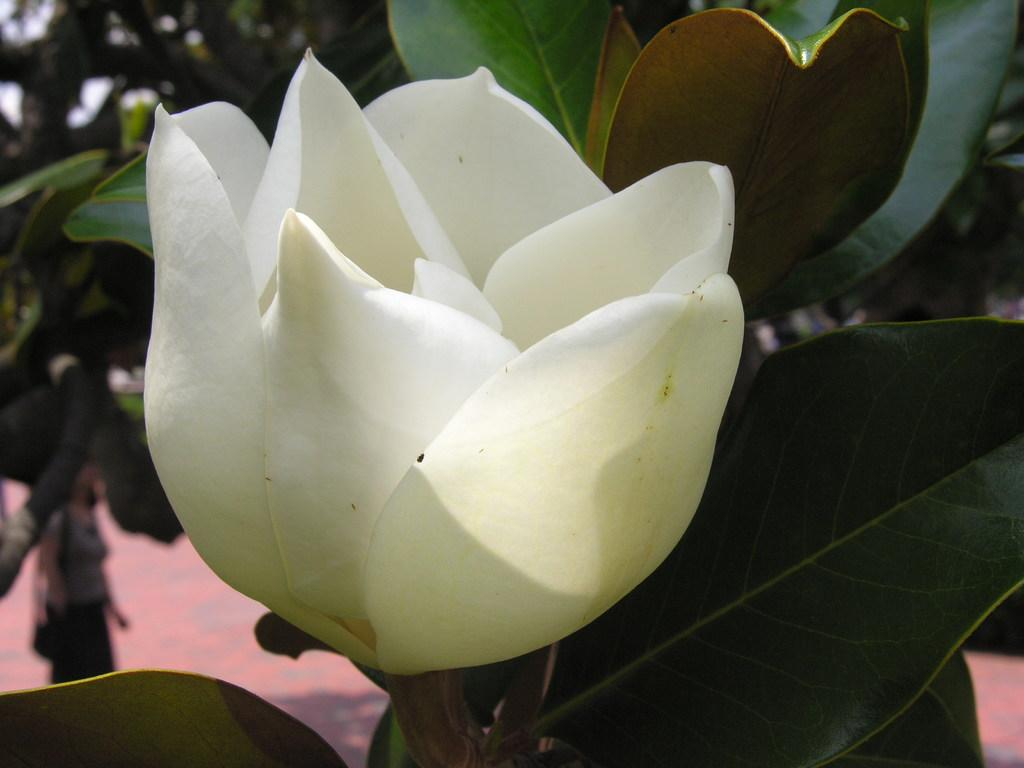What type of flower is in the image? There is a white flower in the image. What else can be seen in the image besides the flower? There are leaves in the image. Can you describe the background of the image? There is a person and trees in the background of the image. How does the person in the background use the impulse to wave at the flower? There is no person using an impulse to wave at the flower in the image; the person is simply present in the background. 